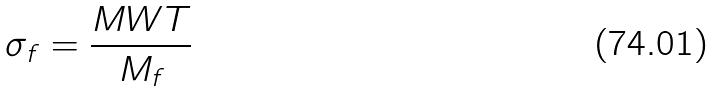Convert formula to latex. <formula><loc_0><loc_0><loc_500><loc_500>\sigma _ { f } = \frac { M W T } { M _ { f } }</formula> 